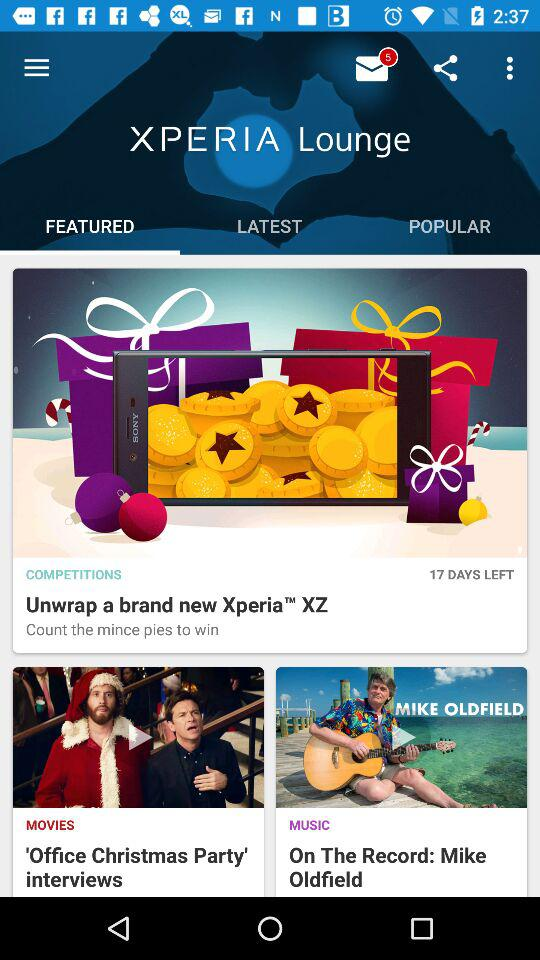Which option is selected in the "XPERIA Lounge"? The selected option is "FEATURED". 